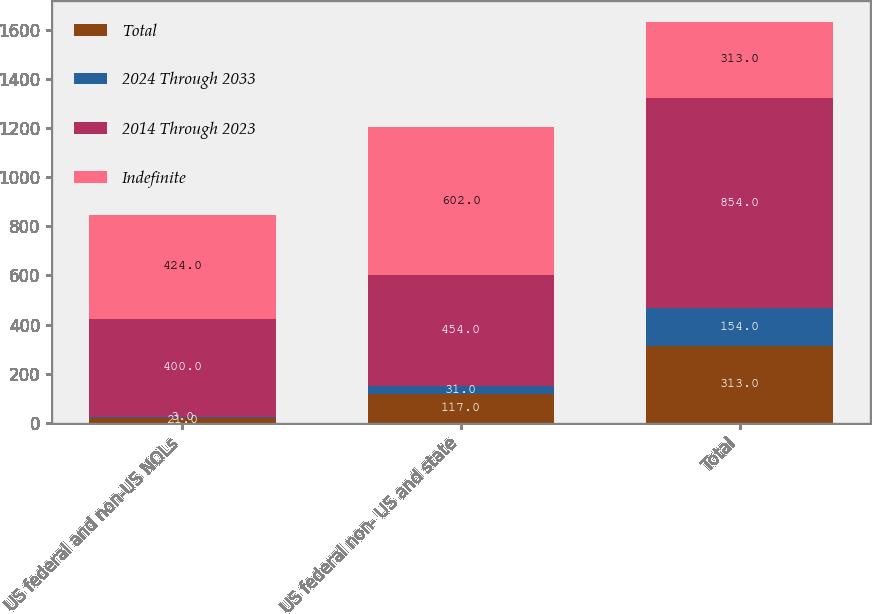Convert chart. <chart><loc_0><loc_0><loc_500><loc_500><stacked_bar_chart><ecel><fcel>US federal and non-US NOLs<fcel>US federal non- US and state<fcel>Total<nl><fcel>Total<fcel>21<fcel>117<fcel>313<nl><fcel>2024 Through 2033<fcel>3<fcel>31<fcel>154<nl><fcel>2014 Through 2023<fcel>400<fcel>454<fcel>854<nl><fcel>Indefinite<fcel>424<fcel>602<fcel>313<nl></chart> 